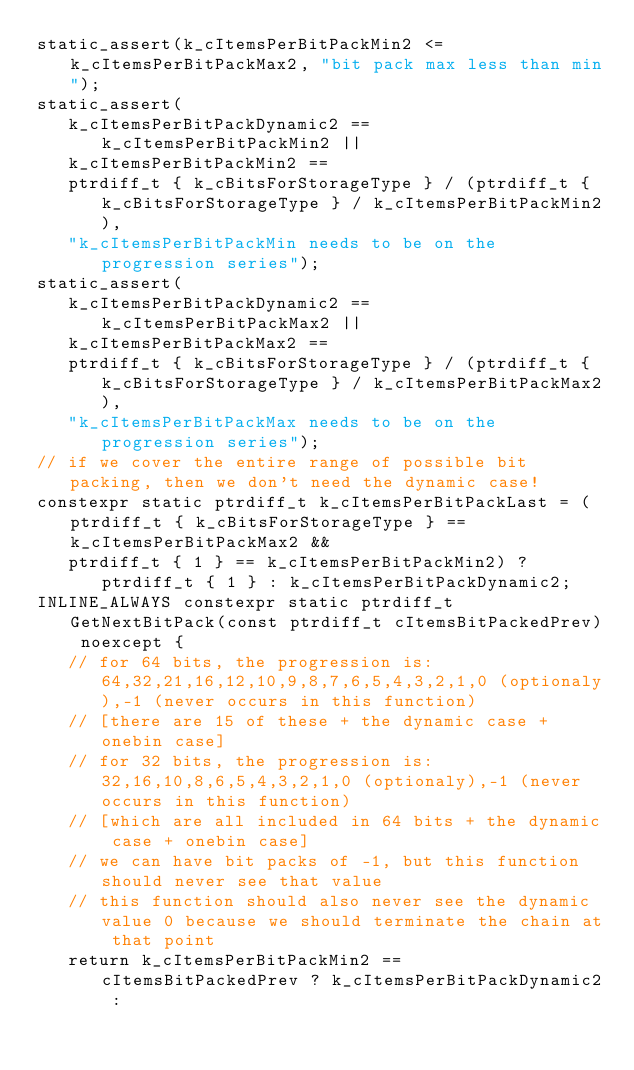Convert code to text. <code><loc_0><loc_0><loc_500><loc_500><_C++_>static_assert(k_cItemsPerBitPackMin2 <= k_cItemsPerBitPackMax2, "bit pack max less than min");
static_assert(
   k_cItemsPerBitPackDynamic2 == k_cItemsPerBitPackMin2 ||
   k_cItemsPerBitPackMin2 ==
   ptrdiff_t { k_cBitsForStorageType } / (ptrdiff_t { k_cBitsForStorageType } / k_cItemsPerBitPackMin2),
   "k_cItemsPerBitPackMin needs to be on the progression series");
static_assert(
   k_cItemsPerBitPackDynamic2 == k_cItemsPerBitPackMax2 ||
   k_cItemsPerBitPackMax2 ==
   ptrdiff_t { k_cBitsForStorageType } / (ptrdiff_t { k_cBitsForStorageType } / k_cItemsPerBitPackMax2),
   "k_cItemsPerBitPackMax needs to be on the progression series");
// if we cover the entire range of possible bit packing, then we don't need the dynamic case!
constexpr static ptrdiff_t k_cItemsPerBitPackLast = (ptrdiff_t { k_cBitsForStorageType } == k_cItemsPerBitPackMax2 &&
   ptrdiff_t { 1 } == k_cItemsPerBitPackMin2) ? ptrdiff_t { 1 } : k_cItemsPerBitPackDynamic2;
INLINE_ALWAYS constexpr static ptrdiff_t GetNextBitPack(const ptrdiff_t cItemsBitPackedPrev) noexcept {
   // for 64 bits, the progression is: 64,32,21,16,12,10,9,8,7,6,5,4,3,2,1,0 (optionaly),-1 (never occurs in this function)
   // [there are 15 of these + the dynamic case + onebin case]
   // for 32 bits, the progression is: 32,16,10,8,6,5,4,3,2,1,0 (optionaly),-1 (never occurs in this function)
   // [which are all included in 64 bits + the dynamic case + onebin case]
   // we can have bit packs of -1, but this function should never see that value
   // this function should also never see the dynamic value 0 because we should terminate the chain at that point
   return k_cItemsPerBitPackMin2 == cItemsBitPackedPrev ? k_cItemsPerBitPackDynamic2 :</code> 